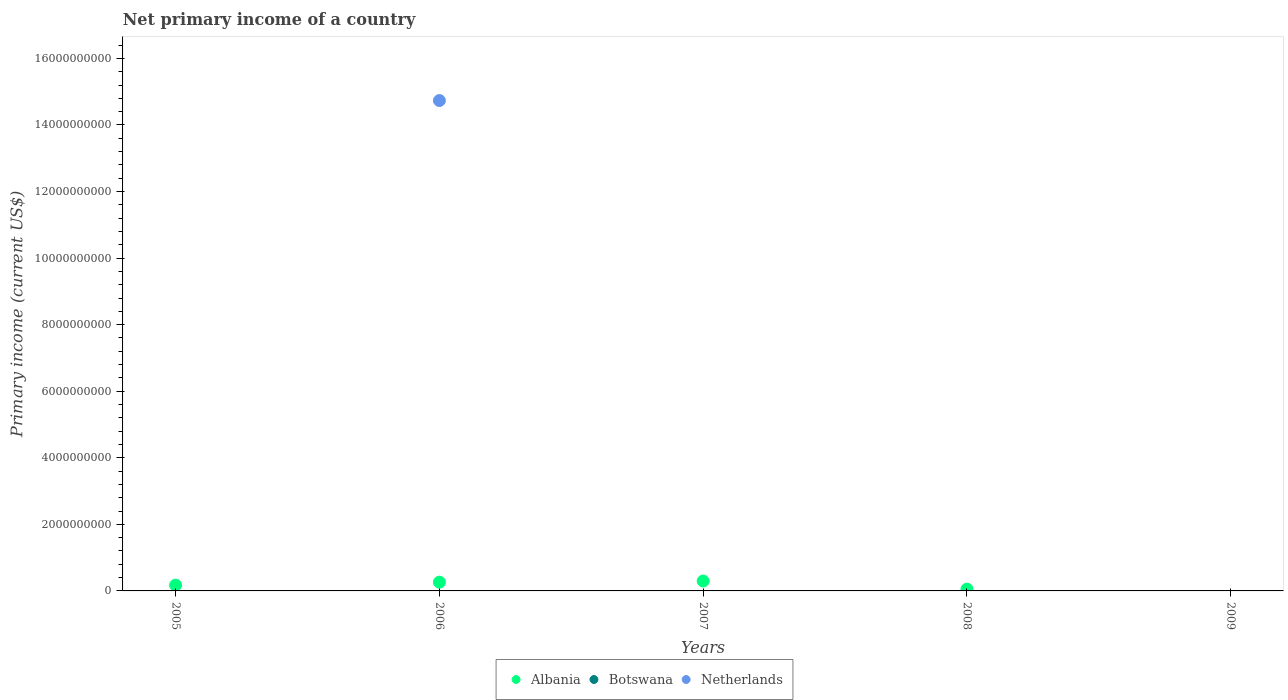How many different coloured dotlines are there?
Your answer should be compact. 2. Is the number of dotlines equal to the number of legend labels?
Provide a short and direct response. No. What is the primary income in Netherlands in 2007?
Your answer should be very brief. 0. Across all years, what is the maximum primary income in Netherlands?
Ensure brevity in your answer.  1.47e+1. What is the difference between the primary income in Netherlands in 2005 and the primary income in Botswana in 2008?
Offer a terse response. 0. What is the average primary income in Albania per year?
Your response must be concise. 1.58e+08. In the year 2006, what is the difference between the primary income in Netherlands and primary income in Albania?
Give a very brief answer. 1.45e+1. In how many years, is the primary income in Botswana greater than 1600000000 US$?
Your answer should be very brief. 0. What is the difference between the highest and the second highest primary income in Albania?
Make the answer very short. 3.43e+07. What is the difference between the highest and the lowest primary income in Albania?
Offer a terse response. 2.97e+08. In how many years, is the primary income in Albania greater than the average primary income in Albania taken over all years?
Your answer should be very brief. 3. Does the primary income in Botswana monotonically increase over the years?
Keep it short and to the point. No. Is the primary income in Botswana strictly greater than the primary income in Albania over the years?
Your answer should be compact. No. Is the primary income in Albania strictly less than the primary income in Netherlands over the years?
Offer a terse response. No. How many dotlines are there?
Provide a short and direct response. 2. How many years are there in the graph?
Provide a short and direct response. 5. What is the difference between two consecutive major ticks on the Y-axis?
Ensure brevity in your answer.  2.00e+09. Does the graph contain any zero values?
Make the answer very short. Yes. Does the graph contain grids?
Make the answer very short. No. Where does the legend appear in the graph?
Your answer should be very brief. Bottom center. How many legend labels are there?
Give a very brief answer. 3. How are the legend labels stacked?
Keep it short and to the point. Horizontal. What is the title of the graph?
Offer a very short reply. Net primary income of a country. Does "Middle East & North Africa (developing only)" appear as one of the legend labels in the graph?
Give a very brief answer. No. What is the label or title of the X-axis?
Your answer should be compact. Years. What is the label or title of the Y-axis?
Provide a succinct answer. Primary income (current US$). What is the Primary income (current US$) in Albania in 2005?
Keep it short and to the point. 1.74e+08. What is the Primary income (current US$) in Netherlands in 2005?
Make the answer very short. 0. What is the Primary income (current US$) of Albania in 2006?
Your answer should be compact. 2.63e+08. What is the Primary income (current US$) of Botswana in 2006?
Make the answer very short. 0. What is the Primary income (current US$) of Netherlands in 2006?
Provide a short and direct response. 1.47e+1. What is the Primary income (current US$) in Albania in 2007?
Make the answer very short. 2.97e+08. What is the Primary income (current US$) in Netherlands in 2007?
Give a very brief answer. 0. What is the Primary income (current US$) in Albania in 2008?
Provide a succinct answer. 5.48e+07. Across all years, what is the maximum Primary income (current US$) in Albania?
Your answer should be very brief. 2.97e+08. Across all years, what is the maximum Primary income (current US$) of Netherlands?
Provide a short and direct response. 1.47e+1. Across all years, what is the minimum Primary income (current US$) in Netherlands?
Your response must be concise. 0. What is the total Primary income (current US$) of Albania in the graph?
Your answer should be compact. 7.89e+08. What is the total Primary income (current US$) in Botswana in the graph?
Give a very brief answer. 0. What is the total Primary income (current US$) in Netherlands in the graph?
Your answer should be very brief. 1.47e+1. What is the difference between the Primary income (current US$) in Albania in 2005 and that in 2006?
Your answer should be very brief. -8.90e+07. What is the difference between the Primary income (current US$) in Albania in 2005 and that in 2007?
Ensure brevity in your answer.  -1.23e+08. What is the difference between the Primary income (current US$) of Albania in 2005 and that in 2008?
Give a very brief answer. 1.19e+08. What is the difference between the Primary income (current US$) of Albania in 2006 and that in 2007?
Your response must be concise. -3.43e+07. What is the difference between the Primary income (current US$) of Albania in 2006 and that in 2008?
Your answer should be very brief. 2.08e+08. What is the difference between the Primary income (current US$) of Albania in 2007 and that in 2008?
Provide a short and direct response. 2.43e+08. What is the difference between the Primary income (current US$) of Albania in 2005 and the Primary income (current US$) of Netherlands in 2006?
Give a very brief answer. -1.46e+1. What is the average Primary income (current US$) in Albania per year?
Your response must be concise. 1.58e+08. What is the average Primary income (current US$) in Netherlands per year?
Offer a terse response. 2.95e+09. In the year 2006, what is the difference between the Primary income (current US$) of Albania and Primary income (current US$) of Netherlands?
Your response must be concise. -1.45e+1. What is the ratio of the Primary income (current US$) of Albania in 2005 to that in 2006?
Ensure brevity in your answer.  0.66. What is the ratio of the Primary income (current US$) of Albania in 2005 to that in 2007?
Your response must be concise. 0.59. What is the ratio of the Primary income (current US$) of Albania in 2005 to that in 2008?
Offer a terse response. 3.18. What is the ratio of the Primary income (current US$) in Albania in 2006 to that in 2007?
Give a very brief answer. 0.88. What is the ratio of the Primary income (current US$) in Albania in 2006 to that in 2008?
Keep it short and to the point. 4.8. What is the ratio of the Primary income (current US$) of Albania in 2007 to that in 2008?
Provide a short and direct response. 5.43. What is the difference between the highest and the second highest Primary income (current US$) of Albania?
Your answer should be very brief. 3.43e+07. What is the difference between the highest and the lowest Primary income (current US$) of Albania?
Offer a terse response. 2.97e+08. What is the difference between the highest and the lowest Primary income (current US$) of Netherlands?
Your answer should be very brief. 1.47e+1. 